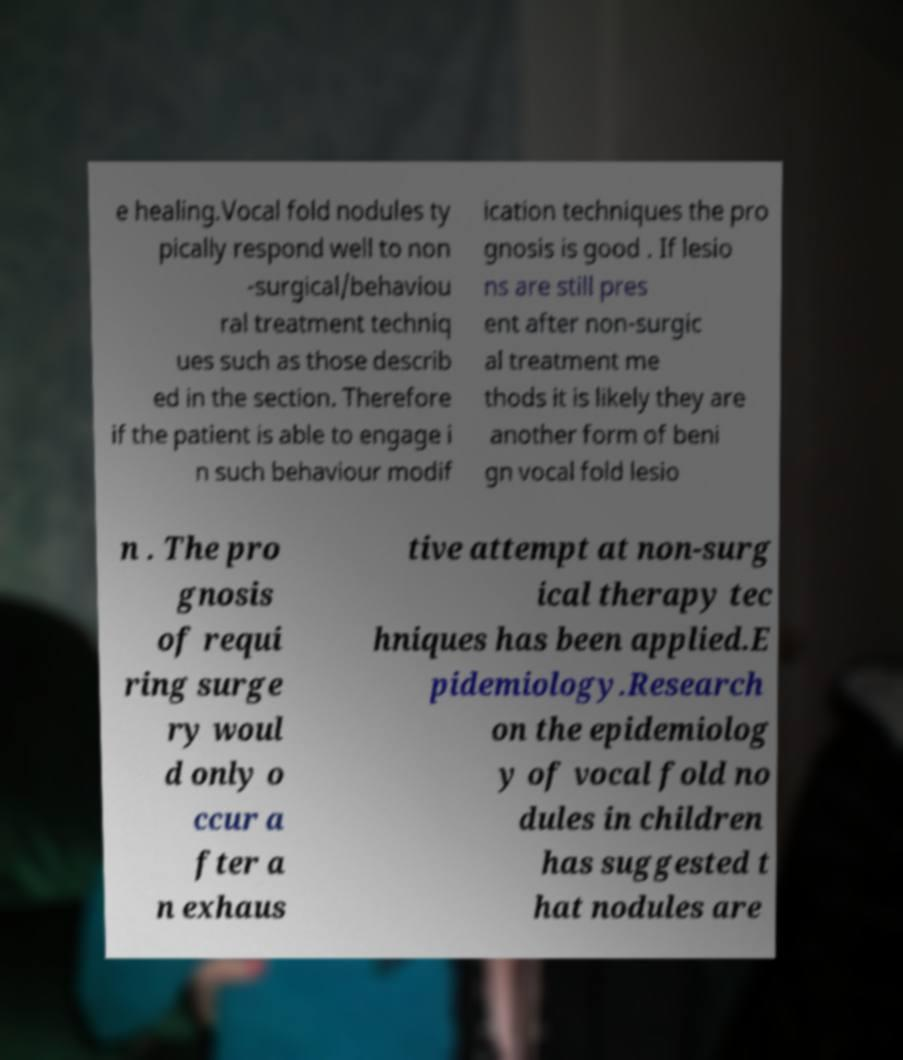Please identify and transcribe the text found in this image. e healing.Vocal fold nodules ty pically respond well to non -surgical/behaviou ral treatment techniq ues such as those describ ed in the section. Therefore if the patient is able to engage i n such behaviour modif ication techniques the pro gnosis is good . If lesio ns are still pres ent after non-surgic al treatment me thods it is likely they are another form of beni gn vocal fold lesio n . The pro gnosis of requi ring surge ry woul d only o ccur a fter a n exhaus tive attempt at non-surg ical therapy tec hniques has been applied.E pidemiology.Research on the epidemiolog y of vocal fold no dules in children has suggested t hat nodules are 